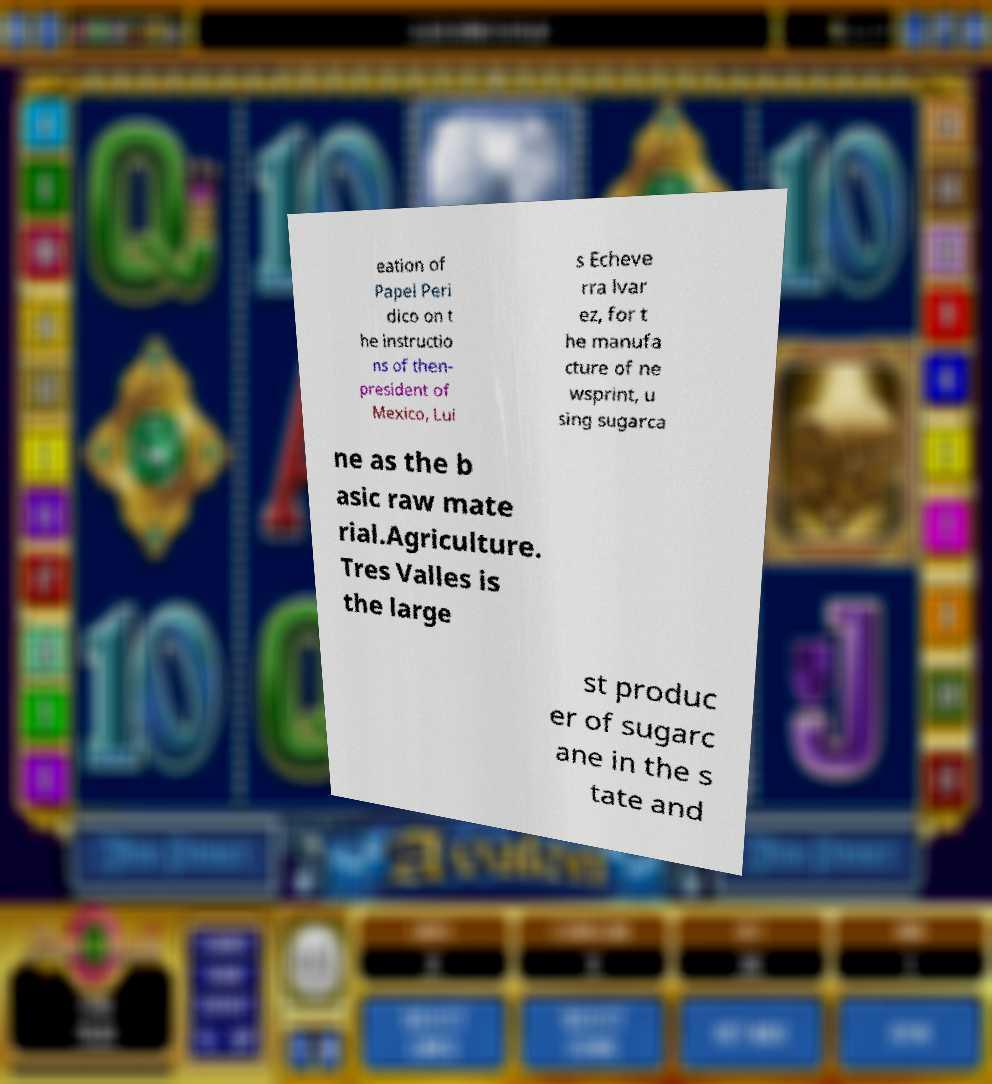What messages or text are displayed in this image? I need them in a readable, typed format. eation of Papel Peri dico on t he instructio ns of then- president of Mexico, Lui s Echeve rra lvar ez, for t he manufa cture of ne wsprint, u sing sugarca ne as the b asic raw mate rial.Agriculture. Tres Valles is the large st produc er of sugarc ane in the s tate and 